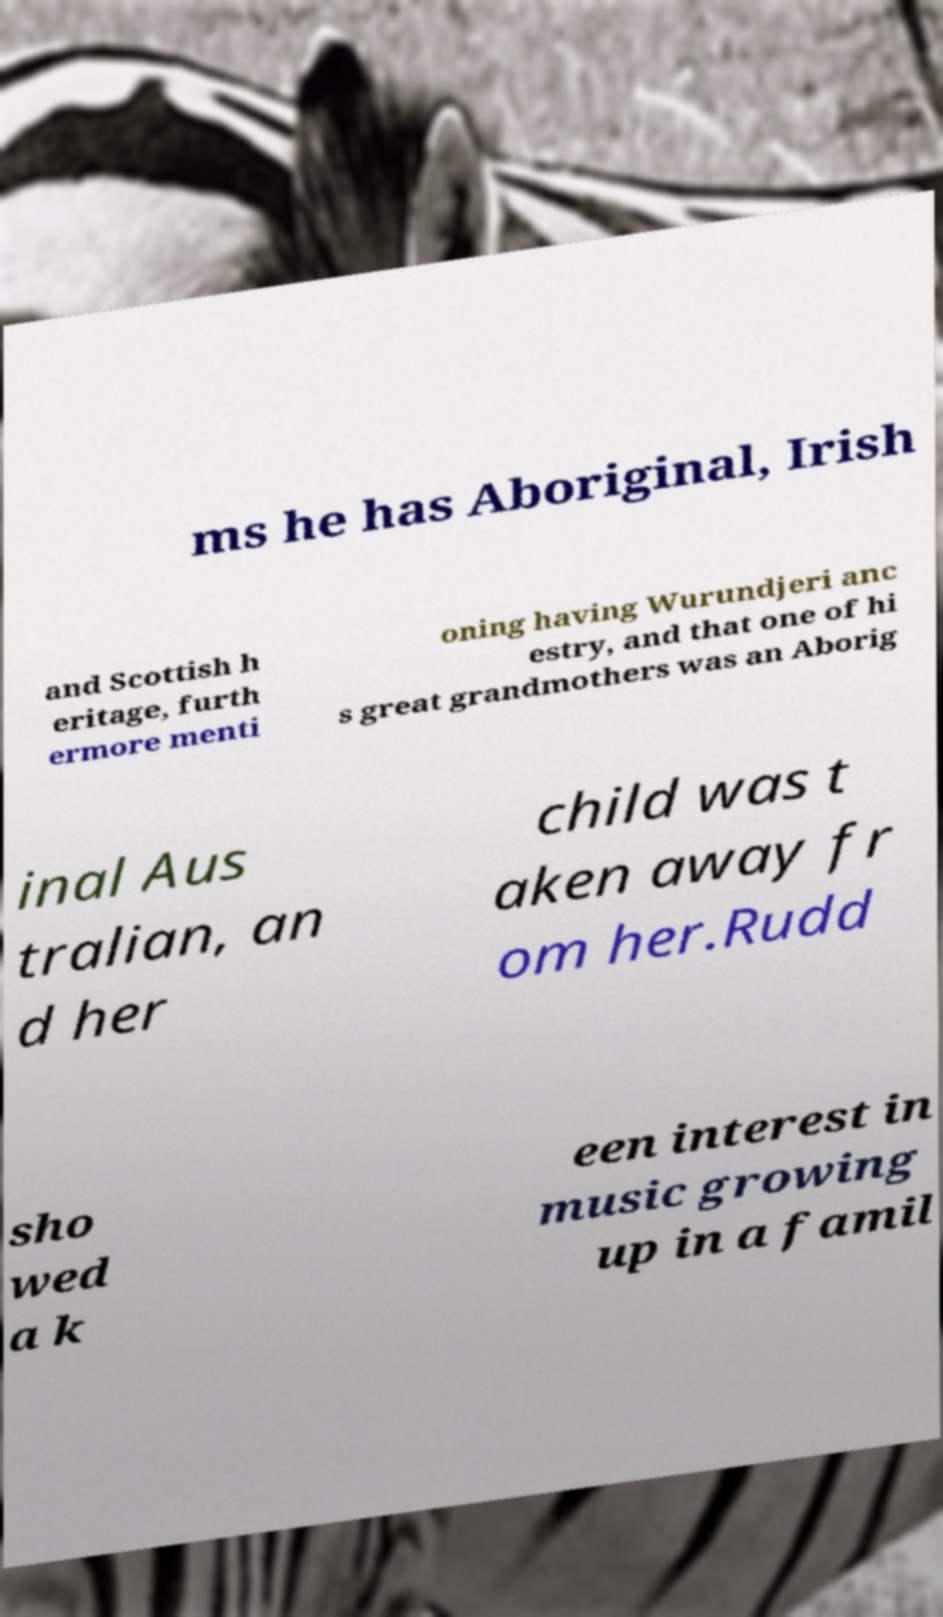Can you read and provide the text displayed in the image?This photo seems to have some interesting text. Can you extract and type it out for me? ms he has Aboriginal, Irish and Scottish h eritage, furth ermore menti oning having Wurundjeri anc estry, and that one of hi s great grandmothers was an Aborig inal Aus tralian, an d her child was t aken away fr om her.Rudd sho wed a k een interest in music growing up in a famil 